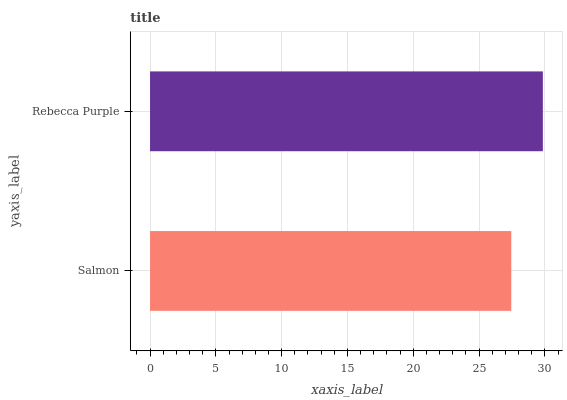Is Salmon the minimum?
Answer yes or no. Yes. Is Rebecca Purple the maximum?
Answer yes or no. Yes. Is Rebecca Purple the minimum?
Answer yes or no. No. Is Rebecca Purple greater than Salmon?
Answer yes or no. Yes. Is Salmon less than Rebecca Purple?
Answer yes or no. Yes. Is Salmon greater than Rebecca Purple?
Answer yes or no. No. Is Rebecca Purple less than Salmon?
Answer yes or no. No. Is Rebecca Purple the high median?
Answer yes or no. Yes. Is Salmon the low median?
Answer yes or no. Yes. Is Salmon the high median?
Answer yes or no. No. Is Rebecca Purple the low median?
Answer yes or no. No. 